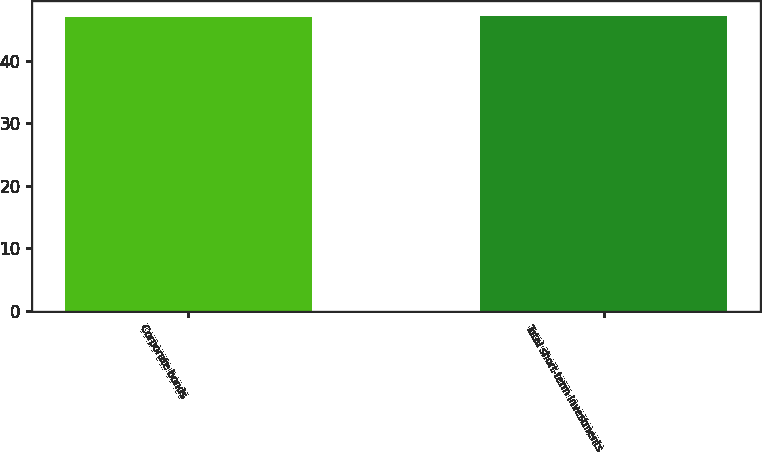<chart> <loc_0><loc_0><loc_500><loc_500><bar_chart><fcel>Corporate bonds<fcel>Total short-term investments<nl><fcel>47<fcel>47.1<nl></chart> 